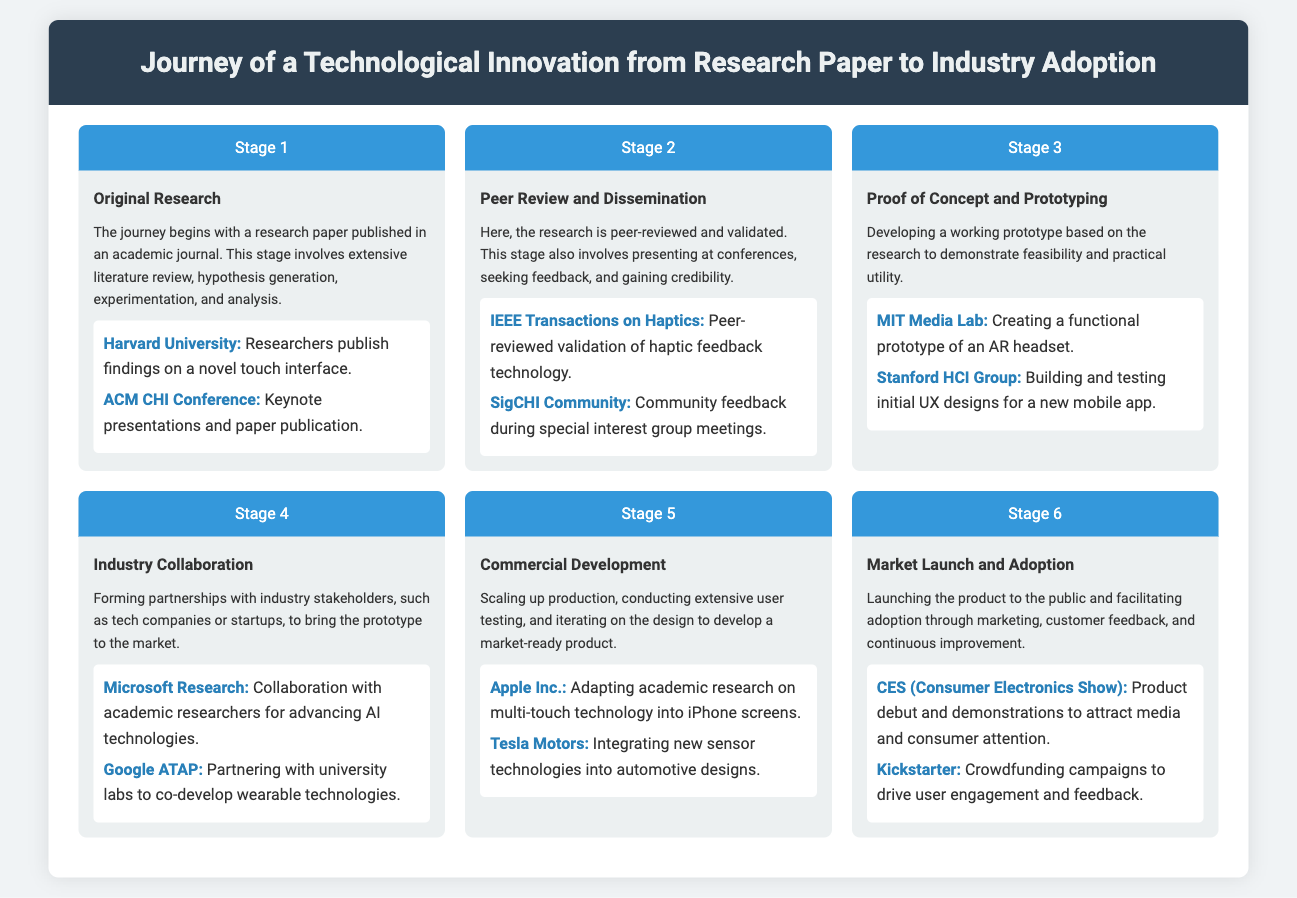what is the title of the infographic? The title of the infographic is presented in the header section.
Answer: Journey of a Technological Innovation from Research Paper to Industry Adoption what is the first stage of the process? The first stage is identified in the timeline as Original Research.
Answer: Original Research who is mentioned as an example in Stage 1? The document lists specific entities in each stage, with Harvard University being mentioned.
Answer: Harvard University what type of publication is referenced in Stage 2? The document notes the type of publication during this stage is a peer-reviewed journal.
Answer: IEEE Transactions on Haptics which company collaborates with researchers in Stage 4? The specific collaboration mentioned in Stage 4 involves industry stakeholders, one of which is Microsoft Research.
Answer: Microsoft Research what is the focus of Stage 5? The main activity highlighted in Stage 5 includes scaling up and user testing for a market-ready product.
Answer: Commercial Development where is the market launch typically showcased? The document cites a specific event where products are often launched, which is CES.
Answer: CES (Consumer Electronics Show) how many stages are outlined in the infographic? The infographic lists the different phases of the innovation journey in a numbered format.
Answer: Six 